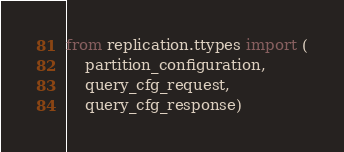<code> <loc_0><loc_0><loc_500><loc_500><_Python_>from replication.ttypes import (
	partition_configuration,
    query_cfg_request,
    query_cfg_response)


</code> 